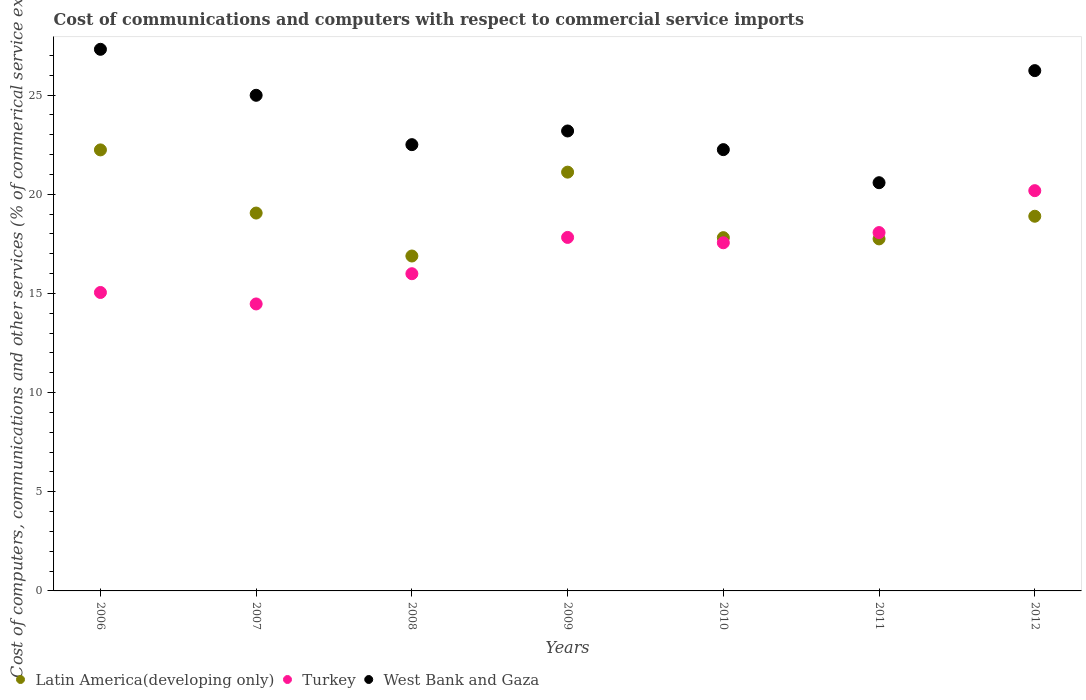What is the cost of communications and computers in Latin America(developing only) in 2010?
Give a very brief answer. 17.81. Across all years, what is the maximum cost of communications and computers in West Bank and Gaza?
Provide a succinct answer. 27.31. Across all years, what is the minimum cost of communications and computers in Latin America(developing only)?
Keep it short and to the point. 16.89. In which year was the cost of communications and computers in Turkey maximum?
Provide a succinct answer. 2012. What is the total cost of communications and computers in West Bank and Gaza in the graph?
Your answer should be compact. 167.08. What is the difference between the cost of communications and computers in West Bank and Gaza in 2008 and that in 2012?
Your answer should be compact. -3.73. What is the difference between the cost of communications and computers in Turkey in 2006 and the cost of communications and computers in West Bank and Gaza in 2007?
Offer a terse response. -9.94. What is the average cost of communications and computers in West Bank and Gaza per year?
Your answer should be very brief. 23.87. In the year 2012, what is the difference between the cost of communications and computers in West Bank and Gaza and cost of communications and computers in Latin America(developing only)?
Provide a succinct answer. 7.34. In how many years, is the cost of communications and computers in West Bank and Gaza greater than 22 %?
Your response must be concise. 6. What is the ratio of the cost of communications and computers in Latin America(developing only) in 2010 to that in 2012?
Offer a very short reply. 0.94. Is the difference between the cost of communications and computers in West Bank and Gaza in 2009 and 2012 greater than the difference between the cost of communications and computers in Latin America(developing only) in 2009 and 2012?
Your response must be concise. No. What is the difference between the highest and the second highest cost of communications and computers in Turkey?
Your response must be concise. 2.11. What is the difference between the highest and the lowest cost of communications and computers in Latin America(developing only)?
Offer a terse response. 5.35. In how many years, is the cost of communications and computers in West Bank and Gaza greater than the average cost of communications and computers in West Bank and Gaza taken over all years?
Keep it short and to the point. 3. Does the cost of communications and computers in West Bank and Gaza monotonically increase over the years?
Make the answer very short. No. How many dotlines are there?
Your response must be concise. 3. How many years are there in the graph?
Ensure brevity in your answer.  7. Does the graph contain any zero values?
Keep it short and to the point. No. Does the graph contain grids?
Give a very brief answer. No. How are the legend labels stacked?
Keep it short and to the point. Horizontal. What is the title of the graph?
Give a very brief answer. Cost of communications and computers with respect to commercial service imports. What is the label or title of the X-axis?
Offer a very short reply. Years. What is the label or title of the Y-axis?
Make the answer very short. Cost of computers, communications and other services (% of commerical service exports). What is the Cost of computers, communications and other services (% of commerical service exports) of Latin America(developing only) in 2006?
Provide a short and direct response. 22.24. What is the Cost of computers, communications and other services (% of commerical service exports) in Turkey in 2006?
Give a very brief answer. 15.05. What is the Cost of computers, communications and other services (% of commerical service exports) of West Bank and Gaza in 2006?
Give a very brief answer. 27.31. What is the Cost of computers, communications and other services (% of commerical service exports) of Latin America(developing only) in 2007?
Provide a short and direct response. 19.05. What is the Cost of computers, communications and other services (% of commerical service exports) of Turkey in 2007?
Offer a very short reply. 14.47. What is the Cost of computers, communications and other services (% of commerical service exports) of West Bank and Gaza in 2007?
Make the answer very short. 24.99. What is the Cost of computers, communications and other services (% of commerical service exports) in Latin America(developing only) in 2008?
Your response must be concise. 16.89. What is the Cost of computers, communications and other services (% of commerical service exports) of Turkey in 2008?
Offer a very short reply. 16. What is the Cost of computers, communications and other services (% of commerical service exports) in West Bank and Gaza in 2008?
Ensure brevity in your answer.  22.5. What is the Cost of computers, communications and other services (% of commerical service exports) in Latin America(developing only) in 2009?
Keep it short and to the point. 21.12. What is the Cost of computers, communications and other services (% of commerical service exports) of Turkey in 2009?
Your answer should be very brief. 17.83. What is the Cost of computers, communications and other services (% of commerical service exports) of West Bank and Gaza in 2009?
Provide a succinct answer. 23.19. What is the Cost of computers, communications and other services (% of commerical service exports) of Latin America(developing only) in 2010?
Offer a terse response. 17.81. What is the Cost of computers, communications and other services (% of commerical service exports) of Turkey in 2010?
Your response must be concise. 17.56. What is the Cost of computers, communications and other services (% of commerical service exports) in West Bank and Gaza in 2010?
Your answer should be compact. 22.25. What is the Cost of computers, communications and other services (% of commerical service exports) of Latin America(developing only) in 2011?
Offer a terse response. 17.75. What is the Cost of computers, communications and other services (% of commerical service exports) in Turkey in 2011?
Offer a terse response. 18.07. What is the Cost of computers, communications and other services (% of commerical service exports) in West Bank and Gaza in 2011?
Your answer should be very brief. 20.58. What is the Cost of computers, communications and other services (% of commerical service exports) of Latin America(developing only) in 2012?
Make the answer very short. 18.89. What is the Cost of computers, communications and other services (% of commerical service exports) in Turkey in 2012?
Offer a terse response. 20.18. What is the Cost of computers, communications and other services (% of commerical service exports) of West Bank and Gaza in 2012?
Offer a very short reply. 26.24. Across all years, what is the maximum Cost of computers, communications and other services (% of commerical service exports) in Latin America(developing only)?
Ensure brevity in your answer.  22.24. Across all years, what is the maximum Cost of computers, communications and other services (% of commerical service exports) of Turkey?
Your response must be concise. 20.18. Across all years, what is the maximum Cost of computers, communications and other services (% of commerical service exports) of West Bank and Gaza?
Your response must be concise. 27.31. Across all years, what is the minimum Cost of computers, communications and other services (% of commerical service exports) in Latin America(developing only)?
Keep it short and to the point. 16.89. Across all years, what is the minimum Cost of computers, communications and other services (% of commerical service exports) of Turkey?
Ensure brevity in your answer.  14.47. Across all years, what is the minimum Cost of computers, communications and other services (% of commerical service exports) in West Bank and Gaza?
Make the answer very short. 20.58. What is the total Cost of computers, communications and other services (% of commerical service exports) in Latin America(developing only) in the graph?
Provide a succinct answer. 133.76. What is the total Cost of computers, communications and other services (% of commerical service exports) in Turkey in the graph?
Your response must be concise. 119.15. What is the total Cost of computers, communications and other services (% of commerical service exports) of West Bank and Gaza in the graph?
Keep it short and to the point. 167.08. What is the difference between the Cost of computers, communications and other services (% of commerical service exports) in Latin America(developing only) in 2006 and that in 2007?
Make the answer very short. 3.18. What is the difference between the Cost of computers, communications and other services (% of commerical service exports) in Turkey in 2006 and that in 2007?
Make the answer very short. 0.58. What is the difference between the Cost of computers, communications and other services (% of commerical service exports) in West Bank and Gaza in 2006 and that in 2007?
Your answer should be compact. 2.32. What is the difference between the Cost of computers, communications and other services (% of commerical service exports) of Latin America(developing only) in 2006 and that in 2008?
Your answer should be compact. 5.35. What is the difference between the Cost of computers, communications and other services (% of commerical service exports) in Turkey in 2006 and that in 2008?
Keep it short and to the point. -0.95. What is the difference between the Cost of computers, communications and other services (% of commerical service exports) in West Bank and Gaza in 2006 and that in 2008?
Make the answer very short. 4.81. What is the difference between the Cost of computers, communications and other services (% of commerical service exports) of Latin America(developing only) in 2006 and that in 2009?
Offer a very short reply. 1.12. What is the difference between the Cost of computers, communications and other services (% of commerical service exports) in Turkey in 2006 and that in 2009?
Your answer should be compact. -2.78. What is the difference between the Cost of computers, communications and other services (% of commerical service exports) of West Bank and Gaza in 2006 and that in 2009?
Keep it short and to the point. 4.12. What is the difference between the Cost of computers, communications and other services (% of commerical service exports) of Latin America(developing only) in 2006 and that in 2010?
Provide a succinct answer. 4.42. What is the difference between the Cost of computers, communications and other services (% of commerical service exports) of Turkey in 2006 and that in 2010?
Keep it short and to the point. -2.51. What is the difference between the Cost of computers, communications and other services (% of commerical service exports) in West Bank and Gaza in 2006 and that in 2010?
Provide a short and direct response. 5.06. What is the difference between the Cost of computers, communications and other services (% of commerical service exports) of Latin America(developing only) in 2006 and that in 2011?
Give a very brief answer. 4.49. What is the difference between the Cost of computers, communications and other services (% of commerical service exports) of Turkey in 2006 and that in 2011?
Offer a very short reply. -3.02. What is the difference between the Cost of computers, communications and other services (% of commerical service exports) of West Bank and Gaza in 2006 and that in 2011?
Keep it short and to the point. 6.73. What is the difference between the Cost of computers, communications and other services (% of commerical service exports) in Latin America(developing only) in 2006 and that in 2012?
Offer a terse response. 3.35. What is the difference between the Cost of computers, communications and other services (% of commerical service exports) in Turkey in 2006 and that in 2012?
Provide a short and direct response. -5.13. What is the difference between the Cost of computers, communications and other services (% of commerical service exports) of West Bank and Gaza in 2006 and that in 2012?
Provide a short and direct response. 1.07. What is the difference between the Cost of computers, communications and other services (% of commerical service exports) in Latin America(developing only) in 2007 and that in 2008?
Provide a succinct answer. 2.17. What is the difference between the Cost of computers, communications and other services (% of commerical service exports) of Turkey in 2007 and that in 2008?
Offer a very short reply. -1.52. What is the difference between the Cost of computers, communications and other services (% of commerical service exports) in West Bank and Gaza in 2007 and that in 2008?
Provide a short and direct response. 2.49. What is the difference between the Cost of computers, communications and other services (% of commerical service exports) of Latin America(developing only) in 2007 and that in 2009?
Keep it short and to the point. -2.06. What is the difference between the Cost of computers, communications and other services (% of commerical service exports) of Turkey in 2007 and that in 2009?
Your answer should be compact. -3.35. What is the difference between the Cost of computers, communications and other services (% of commerical service exports) in West Bank and Gaza in 2007 and that in 2009?
Provide a succinct answer. 1.8. What is the difference between the Cost of computers, communications and other services (% of commerical service exports) of Latin America(developing only) in 2007 and that in 2010?
Make the answer very short. 1.24. What is the difference between the Cost of computers, communications and other services (% of commerical service exports) in Turkey in 2007 and that in 2010?
Keep it short and to the point. -3.08. What is the difference between the Cost of computers, communications and other services (% of commerical service exports) in West Bank and Gaza in 2007 and that in 2010?
Your answer should be very brief. 2.74. What is the difference between the Cost of computers, communications and other services (% of commerical service exports) in Latin America(developing only) in 2007 and that in 2011?
Your response must be concise. 1.3. What is the difference between the Cost of computers, communications and other services (% of commerical service exports) in Turkey in 2007 and that in 2011?
Offer a very short reply. -3.6. What is the difference between the Cost of computers, communications and other services (% of commerical service exports) in West Bank and Gaza in 2007 and that in 2011?
Make the answer very short. 4.41. What is the difference between the Cost of computers, communications and other services (% of commerical service exports) in Latin America(developing only) in 2007 and that in 2012?
Offer a terse response. 0.16. What is the difference between the Cost of computers, communications and other services (% of commerical service exports) of Turkey in 2007 and that in 2012?
Offer a very short reply. -5.71. What is the difference between the Cost of computers, communications and other services (% of commerical service exports) of West Bank and Gaza in 2007 and that in 2012?
Your answer should be very brief. -1.24. What is the difference between the Cost of computers, communications and other services (% of commerical service exports) in Latin America(developing only) in 2008 and that in 2009?
Make the answer very short. -4.23. What is the difference between the Cost of computers, communications and other services (% of commerical service exports) of Turkey in 2008 and that in 2009?
Offer a very short reply. -1.83. What is the difference between the Cost of computers, communications and other services (% of commerical service exports) in West Bank and Gaza in 2008 and that in 2009?
Provide a short and direct response. -0.69. What is the difference between the Cost of computers, communications and other services (% of commerical service exports) in Latin America(developing only) in 2008 and that in 2010?
Offer a terse response. -0.93. What is the difference between the Cost of computers, communications and other services (% of commerical service exports) of Turkey in 2008 and that in 2010?
Provide a short and direct response. -1.56. What is the difference between the Cost of computers, communications and other services (% of commerical service exports) of West Bank and Gaza in 2008 and that in 2010?
Your answer should be compact. 0.25. What is the difference between the Cost of computers, communications and other services (% of commerical service exports) of Latin America(developing only) in 2008 and that in 2011?
Your response must be concise. -0.86. What is the difference between the Cost of computers, communications and other services (% of commerical service exports) in Turkey in 2008 and that in 2011?
Ensure brevity in your answer.  -2.07. What is the difference between the Cost of computers, communications and other services (% of commerical service exports) in West Bank and Gaza in 2008 and that in 2011?
Your answer should be very brief. 1.92. What is the difference between the Cost of computers, communications and other services (% of commerical service exports) in Latin America(developing only) in 2008 and that in 2012?
Ensure brevity in your answer.  -2. What is the difference between the Cost of computers, communications and other services (% of commerical service exports) of Turkey in 2008 and that in 2012?
Keep it short and to the point. -4.19. What is the difference between the Cost of computers, communications and other services (% of commerical service exports) of West Bank and Gaza in 2008 and that in 2012?
Make the answer very short. -3.73. What is the difference between the Cost of computers, communications and other services (% of commerical service exports) in Latin America(developing only) in 2009 and that in 2010?
Ensure brevity in your answer.  3.3. What is the difference between the Cost of computers, communications and other services (% of commerical service exports) of Turkey in 2009 and that in 2010?
Your answer should be very brief. 0.27. What is the difference between the Cost of computers, communications and other services (% of commerical service exports) in West Bank and Gaza in 2009 and that in 2010?
Provide a succinct answer. 0.94. What is the difference between the Cost of computers, communications and other services (% of commerical service exports) in Latin America(developing only) in 2009 and that in 2011?
Give a very brief answer. 3.37. What is the difference between the Cost of computers, communications and other services (% of commerical service exports) in Turkey in 2009 and that in 2011?
Ensure brevity in your answer.  -0.24. What is the difference between the Cost of computers, communications and other services (% of commerical service exports) of West Bank and Gaza in 2009 and that in 2011?
Your answer should be compact. 2.61. What is the difference between the Cost of computers, communications and other services (% of commerical service exports) in Latin America(developing only) in 2009 and that in 2012?
Ensure brevity in your answer.  2.22. What is the difference between the Cost of computers, communications and other services (% of commerical service exports) in Turkey in 2009 and that in 2012?
Your response must be concise. -2.36. What is the difference between the Cost of computers, communications and other services (% of commerical service exports) of West Bank and Gaza in 2009 and that in 2012?
Offer a terse response. -3.04. What is the difference between the Cost of computers, communications and other services (% of commerical service exports) in Latin America(developing only) in 2010 and that in 2011?
Your answer should be very brief. 0.06. What is the difference between the Cost of computers, communications and other services (% of commerical service exports) in Turkey in 2010 and that in 2011?
Make the answer very short. -0.51. What is the difference between the Cost of computers, communications and other services (% of commerical service exports) in West Bank and Gaza in 2010 and that in 2011?
Keep it short and to the point. 1.67. What is the difference between the Cost of computers, communications and other services (% of commerical service exports) of Latin America(developing only) in 2010 and that in 2012?
Provide a short and direct response. -1.08. What is the difference between the Cost of computers, communications and other services (% of commerical service exports) in Turkey in 2010 and that in 2012?
Provide a short and direct response. -2.63. What is the difference between the Cost of computers, communications and other services (% of commerical service exports) in West Bank and Gaza in 2010 and that in 2012?
Your response must be concise. -3.98. What is the difference between the Cost of computers, communications and other services (% of commerical service exports) of Latin America(developing only) in 2011 and that in 2012?
Provide a short and direct response. -1.14. What is the difference between the Cost of computers, communications and other services (% of commerical service exports) in Turkey in 2011 and that in 2012?
Offer a very short reply. -2.11. What is the difference between the Cost of computers, communications and other services (% of commerical service exports) of West Bank and Gaza in 2011 and that in 2012?
Give a very brief answer. -5.65. What is the difference between the Cost of computers, communications and other services (% of commerical service exports) in Latin America(developing only) in 2006 and the Cost of computers, communications and other services (% of commerical service exports) in Turkey in 2007?
Your answer should be very brief. 7.77. What is the difference between the Cost of computers, communications and other services (% of commerical service exports) in Latin America(developing only) in 2006 and the Cost of computers, communications and other services (% of commerical service exports) in West Bank and Gaza in 2007?
Give a very brief answer. -2.75. What is the difference between the Cost of computers, communications and other services (% of commerical service exports) in Turkey in 2006 and the Cost of computers, communications and other services (% of commerical service exports) in West Bank and Gaza in 2007?
Your answer should be very brief. -9.94. What is the difference between the Cost of computers, communications and other services (% of commerical service exports) of Latin America(developing only) in 2006 and the Cost of computers, communications and other services (% of commerical service exports) of Turkey in 2008?
Your answer should be compact. 6.24. What is the difference between the Cost of computers, communications and other services (% of commerical service exports) in Latin America(developing only) in 2006 and the Cost of computers, communications and other services (% of commerical service exports) in West Bank and Gaza in 2008?
Give a very brief answer. -0.26. What is the difference between the Cost of computers, communications and other services (% of commerical service exports) in Turkey in 2006 and the Cost of computers, communications and other services (% of commerical service exports) in West Bank and Gaza in 2008?
Make the answer very short. -7.45. What is the difference between the Cost of computers, communications and other services (% of commerical service exports) of Latin America(developing only) in 2006 and the Cost of computers, communications and other services (% of commerical service exports) of Turkey in 2009?
Give a very brief answer. 4.41. What is the difference between the Cost of computers, communications and other services (% of commerical service exports) in Latin America(developing only) in 2006 and the Cost of computers, communications and other services (% of commerical service exports) in West Bank and Gaza in 2009?
Ensure brevity in your answer.  -0.95. What is the difference between the Cost of computers, communications and other services (% of commerical service exports) of Turkey in 2006 and the Cost of computers, communications and other services (% of commerical service exports) of West Bank and Gaza in 2009?
Your answer should be compact. -8.14. What is the difference between the Cost of computers, communications and other services (% of commerical service exports) in Latin America(developing only) in 2006 and the Cost of computers, communications and other services (% of commerical service exports) in Turkey in 2010?
Your answer should be compact. 4.68. What is the difference between the Cost of computers, communications and other services (% of commerical service exports) in Latin America(developing only) in 2006 and the Cost of computers, communications and other services (% of commerical service exports) in West Bank and Gaza in 2010?
Your answer should be very brief. -0.01. What is the difference between the Cost of computers, communications and other services (% of commerical service exports) in Turkey in 2006 and the Cost of computers, communications and other services (% of commerical service exports) in West Bank and Gaza in 2010?
Keep it short and to the point. -7.2. What is the difference between the Cost of computers, communications and other services (% of commerical service exports) in Latin America(developing only) in 2006 and the Cost of computers, communications and other services (% of commerical service exports) in Turkey in 2011?
Offer a terse response. 4.17. What is the difference between the Cost of computers, communications and other services (% of commerical service exports) in Latin America(developing only) in 2006 and the Cost of computers, communications and other services (% of commerical service exports) in West Bank and Gaza in 2011?
Provide a short and direct response. 1.65. What is the difference between the Cost of computers, communications and other services (% of commerical service exports) in Turkey in 2006 and the Cost of computers, communications and other services (% of commerical service exports) in West Bank and Gaza in 2011?
Give a very brief answer. -5.54. What is the difference between the Cost of computers, communications and other services (% of commerical service exports) of Latin America(developing only) in 2006 and the Cost of computers, communications and other services (% of commerical service exports) of Turkey in 2012?
Your answer should be compact. 2.06. What is the difference between the Cost of computers, communications and other services (% of commerical service exports) in Latin America(developing only) in 2006 and the Cost of computers, communications and other services (% of commerical service exports) in West Bank and Gaza in 2012?
Give a very brief answer. -4. What is the difference between the Cost of computers, communications and other services (% of commerical service exports) of Turkey in 2006 and the Cost of computers, communications and other services (% of commerical service exports) of West Bank and Gaza in 2012?
Your response must be concise. -11.19. What is the difference between the Cost of computers, communications and other services (% of commerical service exports) in Latin America(developing only) in 2007 and the Cost of computers, communications and other services (% of commerical service exports) in Turkey in 2008?
Provide a succinct answer. 3.06. What is the difference between the Cost of computers, communications and other services (% of commerical service exports) of Latin America(developing only) in 2007 and the Cost of computers, communications and other services (% of commerical service exports) of West Bank and Gaza in 2008?
Keep it short and to the point. -3.45. What is the difference between the Cost of computers, communications and other services (% of commerical service exports) of Turkey in 2007 and the Cost of computers, communications and other services (% of commerical service exports) of West Bank and Gaza in 2008?
Provide a short and direct response. -8.03. What is the difference between the Cost of computers, communications and other services (% of commerical service exports) of Latin America(developing only) in 2007 and the Cost of computers, communications and other services (% of commerical service exports) of Turkey in 2009?
Keep it short and to the point. 1.23. What is the difference between the Cost of computers, communications and other services (% of commerical service exports) of Latin America(developing only) in 2007 and the Cost of computers, communications and other services (% of commerical service exports) of West Bank and Gaza in 2009?
Your answer should be very brief. -4.14. What is the difference between the Cost of computers, communications and other services (% of commerical service exports) of Turkey in 2007 and the Cost of computers, communications and other services (% of commerical service exports) of West Bank and Gaza in 2009?
Give a very brief answer. -8.72. What is the difference between the Cost of computers, communications and other services (% of commerical service exports) in Latin America(developing only) in 2007 and the Cost of computers, communications and other services (% of commerical service exports) in Turkey in 2010?
Keep it short and to the point. 1.5. What is the difference between the Cost of computers, communications and other services (% of commerical service exports) of Latin America(developing only) in 2007 and the Cost of computers, communications and other services (% of commerical service exports) of West Bank and Gaza in 2010?
Make the answer very short. -3.2. What is the difference between the Cost of computers, communications and other services (% of commerical service exports) in Turkey in 2007 and the Cost of computers, communications and other services (% of commerical service exports) in West Bank and Gaza in 2010?
Provide a short and direct response. -7.78. What is the difference between the Cost of computers, communications and other services (% of commerical service exports) in Latin America(developing only) in 2007 and the Cost of computers, communications and other services (% of commerical service exports) in Turkey in 2011?
Give a very brief answer. 0.98. What is the difference between the Cost of computers, communications and other services (% of commerical service exports) of Latin America(developing only) in 2007 and the Cost of computers, communications and other services (% of commerical service exports) of West Bank and Gaza in 2011?
Keep it short and to the point. -1.53. What is the difference between the Cost of computers, communications and other services (% of commerical service exports) of Turkey in 2007 and the Cost of computers, communications and other services (% of commerical service exports) of West Bank and Gaza in 2011?
Offer a very short reply. -6.11. What is the difference between the Cost of computers, communications and other services (% of commerical service exports) of Latin America(developing only) in 2007 and the Cost of computers, communications and other services (% of commerical service exports) of Turkey in 2012?
Your answer should be very brief. -1.13. What is the difference between the Cost of computers, communications and other services (% of commerical service exports) of Latin America(developing only) in 2007 and the Cost of computers, communications and other services (% of commerical service exports) of West Bank and Gaza in 2012?
Provide a short and direct response. -7.18. What is the difference between the Cost of computers, communications and other services (% of commerical service exports) of Turkey in 2007 and the Cost of computers, communications and other services (% of commerical service exports) of West Bank and Gaza in 2012?
Make the answer very short. -11.77. What is the difference between the Cost of computers, communications and other services (% of commerical service exports) of Latin America(developing only) in 2008 and the Cost of computers, communications and other services (% of commerical service exports) of Turkey in 2009?
Keep it short and to the point. -0.94. What is the difference between the Cost of computers, communications and other services (% of commerical service exports) of Latin America(developing only) in 2008 and the Cost of computers, communications and other services (% of commerical service exports) of West Bank and Gaza in 2009?
Your answer should be compact. -6.31. What is the difference between the Cost of computers, communications and other services (% of commerical service exports) in Turkey in 2008 and the Cost of computers, communications and other services (% of commerical service exports) in West Bank and Gaza in 2009?
Give a very brief answer. -7.2. What is the difference between the Cost of computers, communications and other services (% of commerical service exports) in Latin America(developing only) in 2008 and the Cost of computers, communications and other services (% of commerical service exports) in Turkey in 2010?
Give a very brief answer. -0.67. What is the difference between the Cost of computers, communications and other services (% of commerical service exports) in Latin America(developing only) in 2008 and the Cost of computers, communications and other services (% of commerical service exports) in West Bank and Gaza in 2010?
Keep it short and to the point. -5.36. What is the difference between the Cost of computers, communications and other services (% of commerical service exports) in Turkey in 2008 and the Cost of computers, communications and other services (% of commerical service exports) in West Bank and Gaza in 2010?
Offer a terse response. -6.26. What is the difference between the Cost of computers, communications and other services (% of commerical service exports) of Latin America(developing only) in 2008 and the Cost of computers, communications and other services (% of commerical service exports) of Turkey in 2011?
Offer a terse response. -1.18. What is the difference between the Cost of computers, communications and other services (% of commerical service exports) in Latin America(developing only) in 2008 and the Cost of computers, communications and other services (% of commerical service exports) in West Bank and Gaza in 2011?
Offer a terse response. -3.7. What is the difference between the Cost of computers, communications and other services (% of commerical service exports) of Turkey in 2008 and the Cost of computers, communications and other services (% of commerical service exports) of West Bank and Gaza in 2011?
Give a very brief answer. -4.59. What is the difference between the Cost of computers, communications and other services (% of commerical service exports) in Latin America(developing only) in 2008 and the Cost of computers, communications and other services (% of commerical service exports) in Turkey in 2012?
Provide a short and direct response. -3.29. What is the difference between the Cost of computers, communications and other services (% of commerical service exports) of Latin America(developing only) in 2008 and the Cost of computers, communications and other services (% of commerical service exports) of West Bank and Gaza in 2012?
Provide a succinct answer. -9.35. What is the difference between the Cost of computers, communications and other services (% of commerical service exports) of Turkey in 2008 and the Cost of computers, communications and other services (% of commerical service exports) of West Bank and Gaza in 2012?
Give a very brief answer. -10.24. What is the difference between the Cost of computers, communications and other services (% of commerical service exports) in Latin America(developing only) in 2009 and the Cost of computers, communications and other services (% of commerical service exports) in Turkey in 2010?
Your response must be concise. 3.56. What is the difference between the Cost of computers, communications and other services (% of commerical service exports) in Latin America(developing only) in 2009 and the Cost of computers, communications and other services (% of commerical service exports) in West Bank and Gaza in 2010?
Your answer should be compact. -1.13. What is the difference between the Cost of computers, communications and other services (% of commerical service exports) in Turkey in 2009 and the Cost of computers, communications and other services (% of commerical service exports) in West Bank and Gaza in 2010?
Keep it short and to the point. -4.43. What is the difference between the Cost of computers, communications and other services (% of commerical service exports) of Latin America(developing only) in 2009 and the Cost of computers, communications and other services (% of commerical service exports) of Turkey in 2011?
Your answer should be compact. 3.05. What is the difference between the Cost of computers, communications and other services (% of commerical service exports) of Latin America(developing only) in 2009 and the Cost of computers, communications and other services (% of commerical service exports) of West Bank and Gaza in 2011?
Give a very brief answer. 0.53. What is the difference between the Cost of computers, communications and other services (% of commerical service exports) in Turkey in 2009 and the Cost of computers, communications and other services (% of commerical service exports) in West Bank and Gaza in 2011?
Offer a very short reply. -2.76. What is the difference between the Cost of computers, communications and other services (% of commerical service exports) in Latin America(developing only) in 2009 and the Cost of computers, communications and other services (% of commerical service exports) in Turkey in 2012?
Your answer should be very brief. 0.93. What is the difference between the Cost of computers, communications and other services (% of commerical service exports) in Latin America(developing only) in 2009 and the Cost of computers, communications and other services (% of commerical service exports) in West Bank and Gaza in 2012?
Provide a short and direct response. -5.12. What is the difference between the Cost of computers, communications and other services (% of commerical service exports) of Turkey in 2009 and the Cost of computers, communications and other services (% of commerical service exports) of West Bank and Gaza in 2012?
Ensure brevity in your answer.  -8.41. What is the difference between the Cost of computers, communications and other services (% of commerical service exports) of Latin America(developing only) in 2010 and the Cost of computers, communications and other services (% of commerical service exports) of Turkey in 2011?
Give a very brief answer. -0.26. What is the difference between the Cost of computers, communications and other services (% of commerical service exports) in Latin America(developing only) in 2010 and the Cost of computers, communications and other services (% of commerical service exports) in West Bank and Gaza in 2011?
Your answer should be very brief. -2.77. What is the difference between the Cost of computers, communications and other services (% of commerical service exports) in Turkey in 2010 and the Cost of computers, communications and other services (% of commerical service exports) in West Bank and Gaza in 2011?
Ensure brevity in your answer.  -3.03. What is the difference between the Cost of computers, communications and other services (% of commerical service exports) in Latin America(developing only) in 2010 and the Cost of computers, communications and other services (% of commerical service exports) in Turkey in 2012?
Your response must be concise. -2.37. What is the difference between the Cost of computers, communications and other services (% of commerical service exports) in Latin America(developing only) in 2010 and the Cost of computers, communications and other services (% of commerical service exports) in West Bank and Gaza in 2012?
Give a very brief answer. -8.42. What is the difference between the Cost of computers, communications and other services (% of commerical service exports) in Turkey in 2010 and the Cost of computers, communications and other services (% of commerical service exports) in West Bank and Gaza in 2012?
Make the answer very short. -8.68. What is the difference between the Cost of computers, communications and other services (% of commerical service exports) in Latin America(developing only) in 2011 and the Cost of computers, communications and other services (% of commerical service exports) in Turkey in 2012?
Offer a very short reply. -2.43. What is the difference between the Cost of computers, communications and other services (% of commerical service exports) in Latin America(developing only) in 2011 and the Cost of computers, communications and other services (% of commerical service exports) in West Bank and Gaza in 2012?
Offer a very short reply. -8.49. What is the difference between the Cost of computers, communications and other services (% of commerical service exports) of Turkey in 2011 and the Cost of computers, communications and other services (% of commerical service exports) of West Bank and Gaza in 2012?
Make the answer very short. -8.17. What is the average Cost of computers, communications and other services (% of commerical service exports) of Latin America(developing only) per year?
Give a very brief answer. 19.11. What is the average Cost of computers, communications and other services (% of commerical service exports) of Turkey per year?
Make the answer very short. 17.02. What is the average Cost of computers, communications and other services (% of commerical service exports) in West Bank and Gaza per year?
Your response must be concise. 23.87. In the year 2006, what is the difference between the Cost of computers, communications and other services (% of commerical service exports) of Latin America(developing only) and Cost of computers, communications and other services (% of commerical service exports) of Turkey?
Offer a very short reply. 7.19. In the year 2006, what is the difference between the Cost of computers, communications and other services (% of commerical service exports) in Latin America(developing only) and Cost of computers, communications and other services (% of commerical service exports) in West Bank and Gaza?
Make the answer very short. -5.07. In the year 2006, what is the difference between the Cost of computers, communications and other services (% of commerical service exports) of Turkey and Cost of computers, communications and other services (% of commerical service exports) of West Bank and Gaza?
Give a very brief answer. -12.26. In the year 2007, what is the difference between the Cost of computers, communications and other services (% of commerical service exports) in Latin America(developing only) and Cost of computers, communications and other services (% of commerical service exports) in Turkey?
Your response must be concise. 4.58. In the year 2007, what is the difference between the Cost of computers, communications and other services (% of commerical service exports) in Latin America(developing only) and Cost of computers, communications and other services (% of commerical service exports) in West Bank and Gaza?
Provide a short and direct response. -5.94. In the year 2007, what is the difference between the Cost of computers, communications and other services (% of commerical service exports) of Turkey and Cost of computers, communications and other services (% of commerical service exports) of West Bank and Gaza?
Offer a terse response. -10.52. In the year 2008, what is the difference between the Cost of computers, communications and other services (% of commerical service exports) of Latin America(developing only) and Cost of computers, communications and other services (% of commerical service exports) of Turkey?
Offer a very short reply. 0.89. In the year 2008, what is the difference between the Cost of computers, communications and other services (% of commerical service exports) of Latin America(developing only) and Cost of computers, communications and other services (% of commerical service exports) of West Bank and Gaza?
Your answer should be compact. -5.62. In the year 2008, what is the difference between the Cost of computers, communications and other services (% of commerical service exports) in Turkey and Cost of computers, communications and other services (% of commerical service exports) in West Bank and Gaza?
Your answer should be compact. -6.51. In the year 2009, what is the difference between the Cost of computers, communications and other services (% of commerical service exports) in Latin America(developing only) and Cost of computers, communications and other services (% of commerical service exports) in Turkey?
Give a very brief answer. 3.29. In the year 2009, what is the difference between the Cost of computers, communications and other services (% of commerical service exports) in Latin America(developing only) and Cost of computers, communications and other services (% of commerical service exports) in West Bank and Gaza?
Provide a short and direct response. -2.08. In the year 2009, what is the difference between the Cost of computers, communications and other services (% of commerical service exports) of Turkey and Cost of computers, communications and other services (% of commerical service exports) of West Bank and Gaza?
Offer a very short reply. -5.37. In the year 2010, what is the difference between the Cost of computers, communications and other services (% of commerical service exports) in Latin America(developing only) and Cost of computers, communications and other services (% of commerical service exports) in Turkey?
Your answer should be compact. 0.26. In the year 2010, what is the difference between the Cost of computers, communications and other services (% of commerical service exports) in Latin America(developing only) and Cost of computers, communications and other services (% of commerical service exports) in West Bank and Gaza?
Make the answer very short. -4.44. In the year 2010, what is the difference between the Cost of computers, communications and other services (% of commerical service exports) of Turkey and Cost of computers, communications and other services (% of commerical service exports) of West Bank and Gaza?
Offer a terse response. -4.7. In the year 2011, what is the difference between the Cost of computers, communications and other services (% of commerical service exports) in Latin America(developing only) and Cost of computers, communications and other services (% of commerical service exports) in Turkey?
Keep it short and to the point. -0.32. In the year 2011, what is the difference between the Cost of computers, communications and other services (% of commerical service exports) of Latin America(developing only) and Cost of computers, communications and other services (% of commerical service exports) of West Bank and Gaza?
Offer a very short reply. -2.83. In the year 2011, what is the difference between the Cost of computers, communications and other services (% of commerical service exports) of Turkey and Cost of computers, communications and other services (% of commerical service exports) of West Bank and Gaza?
Provide a short and direct response. -2.51. In the year 2012, what is the difference between the Cost of computers, communications and other services (% of commerical service exports) in Latin America(developing only) and Cost of computers, communications and other services (% of commerical service exports) in Turkey?
Your response must be concise. -1.29. In the year 2012, what is the difference between the Cost of computers, communications and other services (% of commerical service exports) in Latin America(developing only) and Cost of computers, communications and other services (% of commerical service exports) in West Bank and Gaza?
Provide a succinct answer. -7.34. In the year 2012, what is the difference between the Cost of computers, communications and other services (% of commerical service exports) in Turkey and Cost of computers, communications and other services (% of commerical service exports) in West Bank and Gaza?
Provide a succinct answer. -6.05. What is the ratio of the Cost of computers, communications and other services (% of commerical service exports) in Latin America(developing only) in 2006 to that in 2007?
Keep it short and to the point. 1.17. What is the ratio of the Cost of computers, communications and other services (% of commerical service exports) of Turkey in 2006 to that in 2007?
Offer a very short reply. 1.04. What is the ratio of the Cost of computers, communications and other services (% of commerical service exports) in West Bank and Gaza in 2006 to that in 2007?
Give a very brief answer. 1.09. What is the ratio of the Cost of computers, communications and other services (% of commerical service exports) of Latin America(developing only) in 2006 to that in 2008?
Ensure brevity in your answer.  1.32. What is the ratio of the Cost of computers, communications and other services (% of commerical service exports) of Turkey in 2006 to that in 2008?
Provide a short and direct response. 0.94. What is the ratio of the Cost of computers, communications and other services (% of commerical service exports) of West Bank and Gaza in 2006 to that in 2008?
Your response must be concise. 1.21. What is the ratio of the Cost of computers, communications and other services (% of commerical service exports) of Latin America(developing only) in 2006 to that in 2009?
Provide a succinct answer. 1.05. What is the ratio of the Cost of computers, communications and other services (% of commerical service exports) in Turkey in 2006 to that in 2009?
Your response must be concise. 0.84. What is the ratio of the Cost of computers, communications and other services (% of commerical service exports) of West Bank and Gaza in 2006 to that in 2009?
Ensure brevity in your answer.  1.18. What is the ratio of the Cost of computers, communications and other services (% of commerical service exports) of Latin America(developing only) in 2006 to that in 2010?
Offer a very short reply. 1.25. What is the ratio of the Cost of computers, communications and other services (% of commerical service exports) in Turkey in 2006 to that in 2010?
Provide a short and direct response. 0.86. What is the ratio of the Cost of computers, communications and other services (% of commerical service exports) of West Bank and Gaza in 2006 to that in 2010?
Make the answer very short. 1.23. What is the ratio of the Cost of computers, communications and other services (% of commerical service exports) of Latin America(developing only) in 2006 to that in 2011?
Your answer should be very brief. 1.25. What is the ratio of the Cost of computers, communications and other services (% of commerical service exports) in Turkey in 2006 to that in 2011?
Keep it short and to the point. 0.83. What is the ratio of the Cost of computers, communications and other services (% of commerical service exports) of West Bank and Gaza in 2006 to that in 2011?
Your answer should be very brief. 1.33. What is the ratio of the Cost of computers, communications and other services (% of commerical service exports) in Latin America(developing only) in 2006 to that in 2012?
Make the answer very short. 1.18. What is the ratio of the Cost of computers, communications and other services (% of commerical service exports) in Turkey in 2006 to that in 2012?
Offer a very short reply. 0.75. What is the ratio of the Cost of computers, communications and other services (% of commerical service exports) in West Bank and Gaza in 2006 to that in 2012?
Provide a short and direct response. 1.04. What is the ratio of the Cost of computers, communications and other services (% of commerical service exports) in Latin America(developing only) in 2007 to that in 2008?
Your response must be concise. 1.13. What is the ratio of the Cost of computers, communications and other services (% of commerical service exports) of Turkey in 2007 to that in 2008?
Offer a terse response. 0.9. What is the ratio of the Cost of computers, communications and other services (% of commerical service exports) of West Bank and Gaza in 2007 to that in 2008?
Provide a succinct answer. 1.11. What is the ratio of the Cost of computers, communications and other services (% of commerical service exports) in Latin America(developing only) in 2007 to that in 2009?
Keep it short and to the point. 0.9. What is the ratio of the Cost of computers, communications and other services (% of commerical service exports) of Turkey in 2007 to that in 2009?
Your answer should be compact. 0.81. What is the ratio of the Cost of computers, communications and other services (% of commerical service exports) of West Bank and Gaza in 2007 to that in 2009?
Your response must be concise. 1.08. What is the ratio of the Cost of computers, communications and other services (% of commerical service exports) of Latin America(developing only) in 2007 to that in 2010?
Your response must be concise. 1.07. What is the ratio of the Cost of computers, communications and other services (% of commerical service exports) of Turkey in 2007 to that in 2010?
Provide a succinct answer. 0.82. What is the ratio of the Cost of computers, communications and other services (% of commerical service exports) in West Bank and Gaza in 2007 to that in 2010?
Provide a succinct answer. 1.12. What is the ratio of the Cost of computers, communications and other services (% of commerical service exports) of Latin America(developing only) in 2007 to that in 2011?
Your response must be concise. 1.07. What is the ratio of the Cost of computers, communications and other services (% of commerical service exports) of Turkey in 2007 to that in 2011?
Your answer should be very brief. 0.8. What is the ratio of the Cost of computers, communications and other services (% of commerical service exports) in West Bank and Gaza in 2007 to that in 2011?
Offer a very short reply. 1.21. What is the ratio of the Cost of computers, communications and other services (% of commerical service exports) in Latin America(developing only) in 2007 to that in 2012?
Give a very brief answer. 1.01. What is the ratio of the Cost of computers, communications and other services (% of commerical service exports) in Turkey in 2007 to that in 2012?
Your answer should be very brief. 0.72. What is the ratio of the Cost of computers, communications and other services (% of commerical service exports) of West Bank and Gaza in 2007 to that in 2012?
Make the answer very short. 0.95. What is the ratio of the Cost of computers, communications and other services (% of commerical service exports) of Latin America(developing only) in 2008 to that in 2009?
Provide a succinct answer. 0.8. What is the ratio of the Cost of computers, communications and other services (% of commerical service exports) in Turkey in 2008 to that in 2009?
Offer a very short reply. 0.9. What is the ratio of the Cost of computers, communications and other services (% of commerical service exports) of West Bank and Gaza in 2008 to that in 2009?
Ensure brevity in your answer.  0.97. What is the ratio of the Cost of computers, communications and other services (% of commerical service exports) in Latin America(developing only) in 2008 to that in 2010?
Offer a very short reply. 0.95. What is the ratio of the Cost of computers, communications and other services (% of commerical service exports) of Turkey in 2008 to that in 2010?
Offer a very short reply. 0.91. What is the ratio of the Cost of computers, communications and other services (% of commerical service exports) of West Bank and Gaza in 2008 to that in 2010?
Keep it short and to the point. 1.01. What is the ratio of the Cost of computers, communications and other services (% of commerical service exports) in Latin America(developing only) in 2008 to that in 2011?
Your answer should be very brief. 0.95. What is the ratio of the Cost of computers, communications and other services (% of commerical service exports) in Turkey in 2008 to that in 2011?
Provide a succinct answer. 0.89. What is the ratio of the Cost of computers, communications and other services (% of commerical service exports) of West Bank and Gaza in 2008 to that in 2011?
Offer a very short reply. 1.09. What is the ratio of the Cost of computers, communications and other services (% of commerical service exports) of Latin America(developing only) in 2008 to that in 2012?
Offer a terse response. 0.89. What is the ratio of the Cost of computers, communications and other services (% of commerical service exports) in Turkey in 2008 to that in 2012?
Offer a very short reply. 0.79. What is the ratio of the Cost of computers, communications and other services (% of commerical service exports) in West Bank and Gaza in 2008 to that in 2012?
Give a very brief answer. 0.86. What is the ratio of the Cost of computers, communications and other services (% of commerical service exports) of Latin America(developing only) in 2009 to that in 2010?
Ensure brevity in your answer.  1.19. What is the ratio of the Cost of computers, communications and other services (% of commerical service exports) in Turkey in 2009 to that in 2010?
Provide a succinct answer. 1.02. What is the ratio of the Cost of computers, communications and other services (% of commerical service exports) in West Bank and Gaza in 2009 to that in 2010?
Provide a short and direct response. 1.04. What is the ratio of the Cost of computers, communications and other services (% of commerical service exports) of Latin America(developing only) in 2009 to that in 2011?
Keep it short and to the point. 1.19. What is the ratio of the Cost of computers, communications and other services (% of commerical service exports) in Turkey in 2009 to that in 2011?
Offer a terse response. 0.99. What is the ratio of the Cost of computers, communications and other services (% of commerical service exports) of West Bank and Gaza in 2009 to that in 2011?
Your answer should be very brief. 1.13. What is the ratio of the Cost of computers, communications and other services (% of commerical service exports) of Latin America(developing only) in 2009 to that in 2012?
Your answer should be very brief. 1.12. What is the ratio of the Cost of computers, communications and other services (% of commerical service exports) of Turkey in 2009 to that in 2012?
Ensure brevity in your answer.  0.88. What is the ratio of the Cost of computers, communications and other services (% of commerical service exports) of West Bank and Gaza in 2009 to that in 2012?
Your response must be concise. 0.88. What is the ratio of the Cost of computers, communications and other services (% of commerical service exports) of Turkey in 2010 to that in 2011?
Ensure brevity in your answer.  0.97. What is the ratio of the Cost of computers, communications and other services (% of commerical service exports) of West Bank and Gaza in 2010 to that in 2011?
Provide a succinct answer. 1.08. What is the ratio of the Cost of computers, communications and other services (% of commerical service exports) of Latin America(developing only) in 2010 to that in 2012?
Offer a terse response. 0.94. What is the ratio of the Cost of computers, communications and other services (% of commerical service exports) of Turkey in 2010 to that in 2012?
Offer a very short reply. 0.87. What is the ratio of the Cost of computers, communications and other services (% of commerical service exports) of West Bank and Gaza in 2010 to that in 2012?
Keep it short and to the point. 0.85. What is the ratio of the Cost of computers, communications and other services (% of commerical service exports) of Latin America(developing only) in 2011 to that in 2012?
Give a very brief answer. 0.94. What is the ratio of the Cost of computers, communications and other services (% of commerical service exports) in Turkey in 2011 to that in 2012?
Provide a short and direct response. 0.9. What is the ratio of the Cost of computers, communications and other services (% of commerical service exports) in West Bank and Gaza in 2011 to that in 2012?
Give a very brief answer. 0.78. What is the difference between the highest and the second highest Cost of computers, communications and other services (% of commerical service exports) in Latin America(developing only)?
Your response must be concise. 1.12. What is the difference between the highest and the second highest Cost of computers, communications and other services (% of commerical service exports) of Turkey?
Offer a very short reply. 2.11. What is the difference between the highest and the second highest Cost of computers, communications and other services (% of commerical service exports) in West Bank and Gaza?
Offer a very short reply. 1.07. What is the difference between the highest and the lowest Cost of computers, communications and other services (% of commerical service exports) in Latin America(developing only)?
Keep it short and to the point. 5.35. What is the difference between the highest and the lowest Cost of computers, communications and other services (% of commerical service exports) of Turkey?
Keep it short and to the point. 5.71. What is the difference between the highest and the lowest Cost of computers, communications and other services (% of commerical service exports) of West Bank and Gaza?
Ensure brevity in your answer.  6.73. 